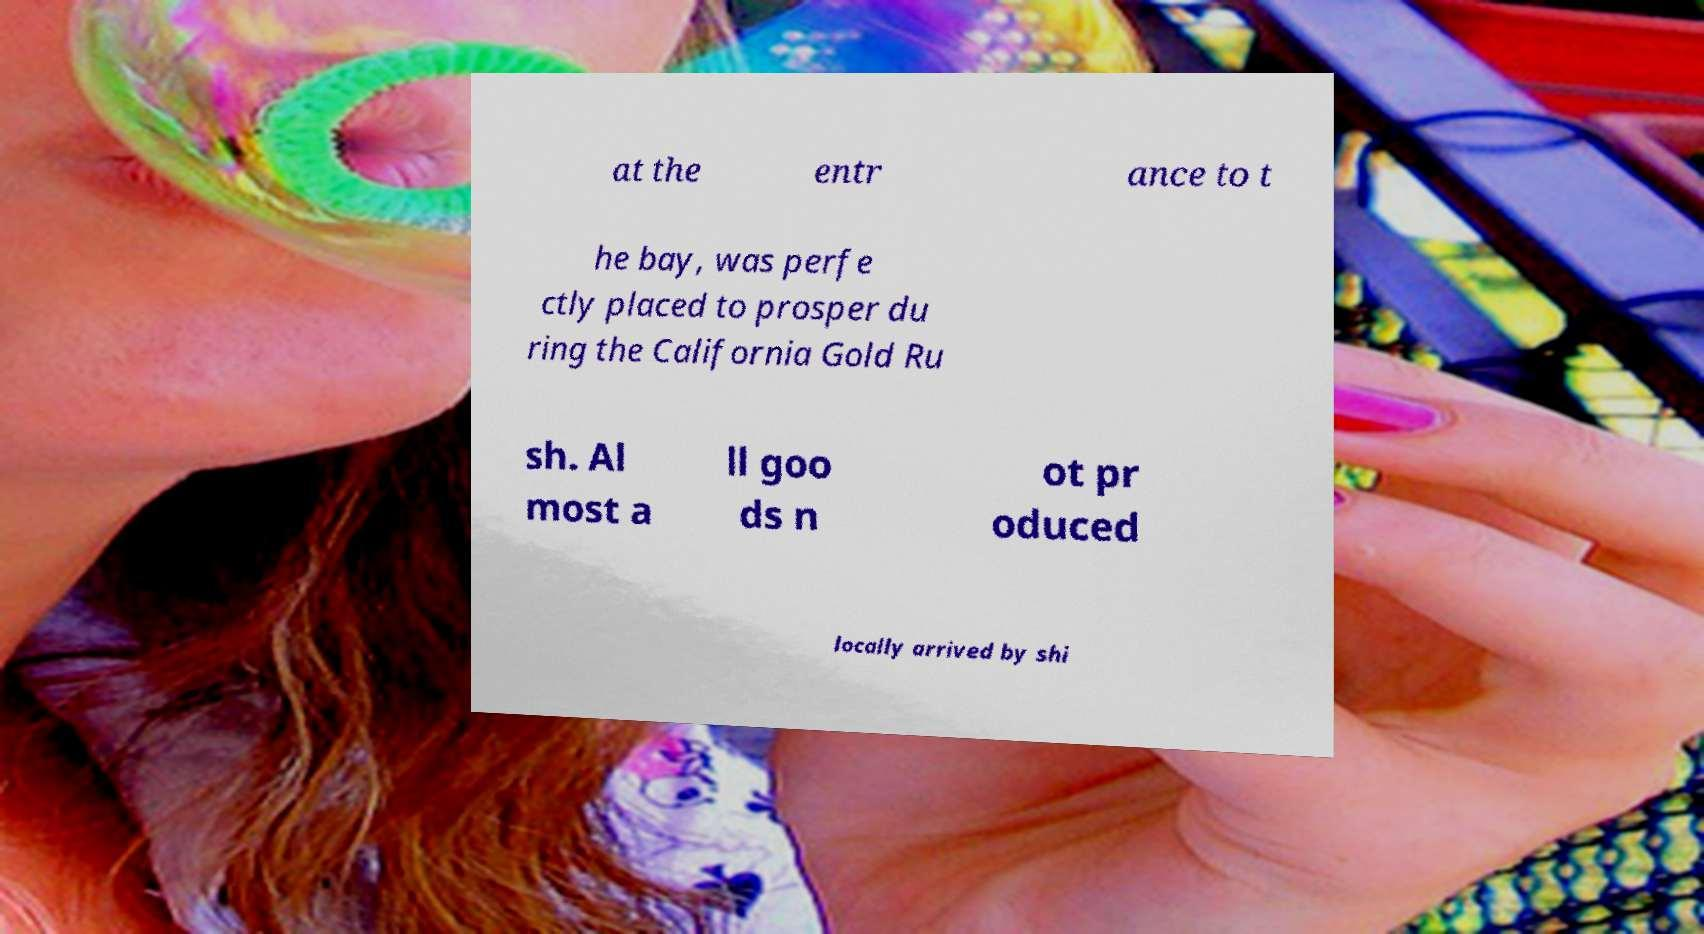What messages or text are displayed in this image? I need them in a readable, typed format. at the entr ance to t he bay, was perfe ctly placed to prosper du ring the California Gold Ru sh. Al most a ll goo ds n ot pr oduced locally arrived by shi 